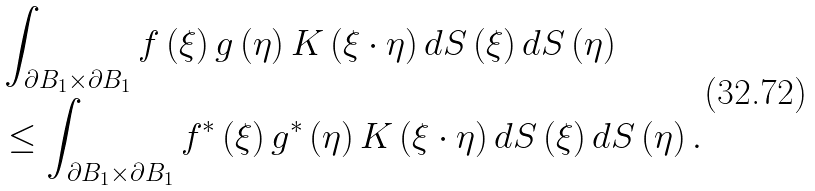<formula> <loc_0><loc_0><loc_500><loc_500>& \int _ { \partial B _ { 1 } \times \partial B _ { 1 } } f \left ( \xi \right ) g \left ( \eta \right ) K \left ( \xi \cdot \eta \right ) d S \left ( \xi \right ) d S \left ( \eta \right ) \\ & \leq \int _ { \partial B _ { 1 } \times \partial B _ { 1 } } f ^ { \ast } \left ( \xi \right ) g ^ { \ast } \left ( \eta \right ) K \left ( \xi \cdot \eta \right ) d S \left ( \xi \right ) d S \left ( \eta \right ) .</formula> 